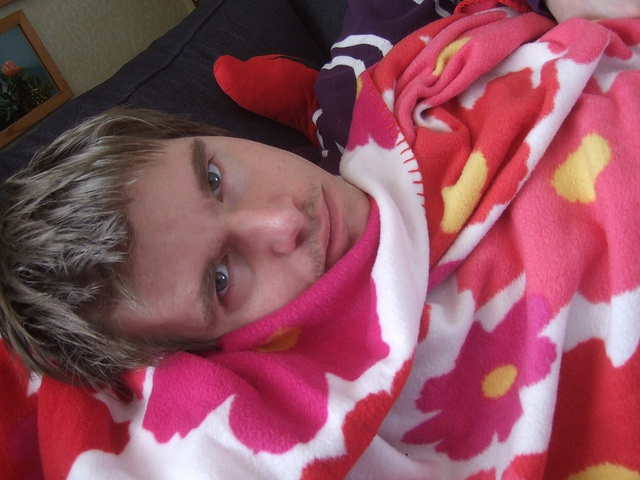Describe the objects in this image and their specific colors. I can see people in maroon, brown, and lavender tones and couch in maroon, black, and gray tones in this image. 